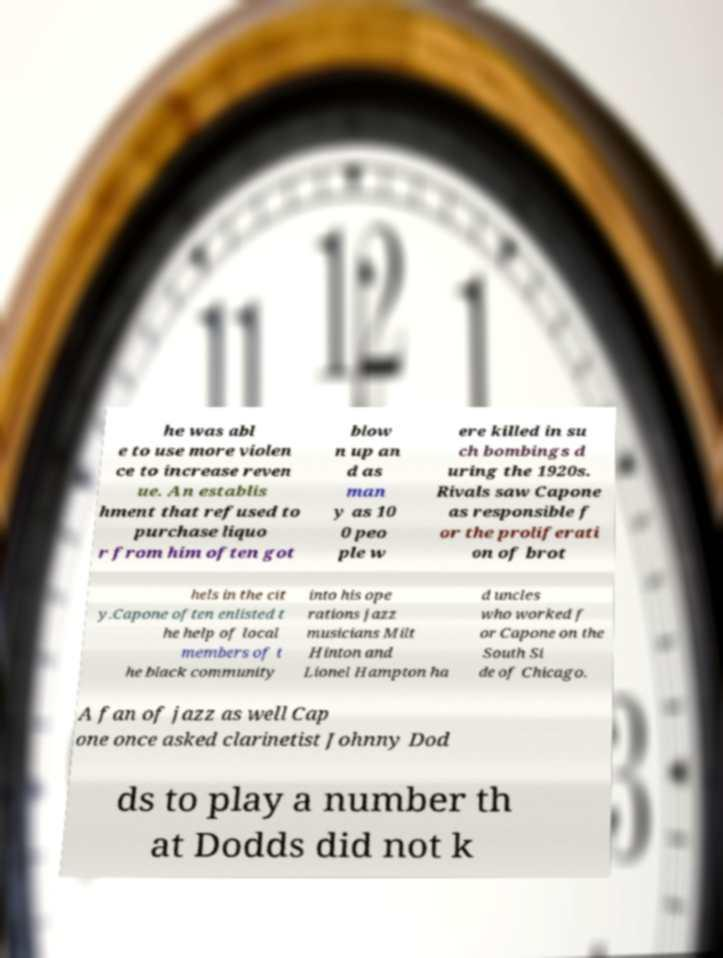Please identify and transcribe the text found in this image. he was abl e to use more violen ce to increase reven ue. An establis hment that refused to purchase liquo r from him often got blow n up an d as man y as 10 0 peo ple w ere killed in su ch bombings d uring the 1920s. Rivals saw Capone as responsible f or the proliferati on of brot hels in the cit y.Capone often enlisted t he help of local members of t he black community into his ope rations jazz musicians Milt Hinton and Lionel Hampton ha d uncles who worked f or Capone on the South Si de of Chicago. A fan of jazz as well Cap one once asked clarinetist Johnny Dod ds to play a number th at Dodds did not k 